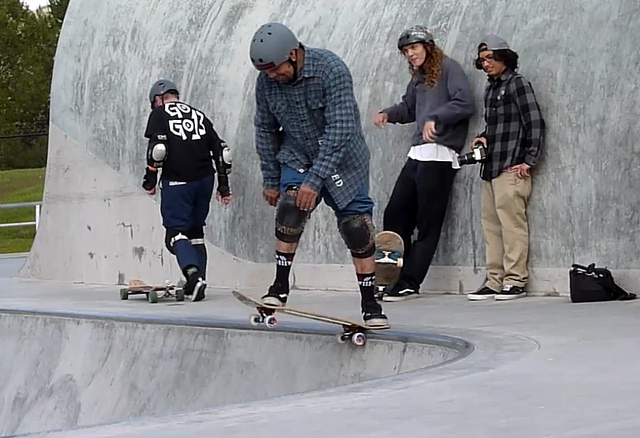Identify and read out the text in this image. GO GO GO 13 ED 